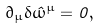Convert formula to latex. <formula><loc_0><loc_0><loc_500><loc_500>\partial _ { \mu } \delta \hat { \omega } ^ { \mu } = 0 ,</formula> 